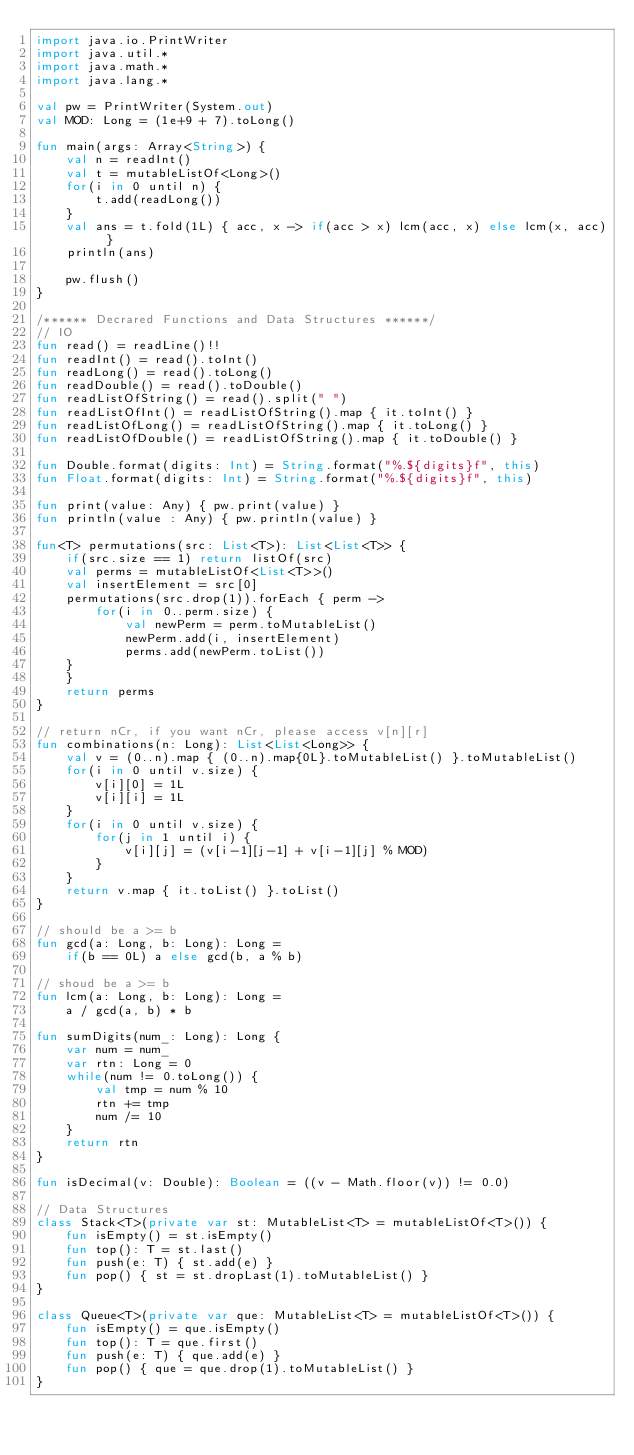<code> <loc_0><loc_0><loc_500><loc_500><_Kotlin_>import java.io.PrintWriter
import java.util.*
import java.math.*
import java.lang.*

val pw = PrintWriter(System.out)
val MOD: Long = (1e+9 + 7).toLong()

fun main(args: Array<String>) {
    val n = readInt()
    val t = mutableListOf<Long>()
    for(i in 0 until n) {
        t.add(readLong())
    }
    val ans = t.fold(1L) { acc, x -> if(acc > x) lcm(acc, x) else lcm(x, acc) }
    println(ans)
    
    pw.flush()
}

/****** Decrared Functions and Data Structures ******/
// IO
fun read() = readLine()!!
fun readInt() = read().toInt()
fun readLong() = read().toLong()
fun readDouble() = read().toDouble()
fun readListOfString() = read().split(" ")
fun readListOfInt() = readListOfString().map { it.toInt() }
fun readListOfLong() = readListOfString().map { it.toLong() }
fun readListOfDouble() = readListOfString().map { it.toDouble() }

fun Double.format(digits: Int) = String.format("%.${digits}f", this)
fun Float.format(digits: Int) = String.format("%.${digits}f", this)

fun print(value: Any) { pw.print(value) }
fun println(value : Any) { pw.println(value) }

fun<T> permutations(src: List<T>): List<List<T>> {
    if(src.size == 1) return listOf(src)
    val perms = mutableListOf<List<T>>()
    val insertElement = src[0]
    permutations(src.drop(1)).forEach { perm ->
        for(i in 0..perm.size) {
            val newPerm = perm.toMutableList()
            newPerm.add(i, insertElement)
            perms.add(newPerm.toList())
    }
    }
    return perms
}

// return nCr, if you want nCr, please access v[n][r]
fun combinations(n: Long): List<List<Long>> {
    val v = (0..n).map { (0..n).map{0L}.toMutableList() }.toMutableList()
    for(i in 0 until v.size) {
        v[i][0] = 1L
        v[i][i] = 1L
    }
    for(i in 0 until v.size) {
        for(j in 1 until i) {
            v[i][j] = (v[i-1][j-1] + v[i-1][j] % MOD)
        }
    }
    return v.map { it.toList() }.toList()
}

// should be a >= b
fun gcd(a: Long, b: Long): Long = 
    if(b == 0L) a else gcd(b, a % b)

// shoud be a >= b
fun lcm(a: Long, b: Long): Long = 
    a / gcd(a, b) * b

fun sumDigits(num_: Long): Long {
    var num = num_
    var rtn: Long = 0
    while(num != 0.toLong()) {
        val tmp = num % 10
        rtn += tmp
        num /= 10
    }
    return rtn
}

fun isDecimal(v: Double): Boolean = ((v - Math.floor(v)) != 0.0)

// Data Structures
class Stack<T>(private var st: MutableList<T> = mutableListOf<T>()) {
    fun isEmpty() = st.isEmpty()
    fun top(): T = st.last()
    fun push(e: T) { st.add(e) }
    fun pop() { st = st.dropLast(1).toMutableList() }
}

class Queue<T>(private var que: MutableList<T> = mutableListOf<T>()) {
    fun isEmpty() = que.isEmpty()
    fun top(): T = que.first()
    fun push(e: T) { que.add(e) }
    fun pop() { que = que.drop(1).toMutableList() }
}
</code> 